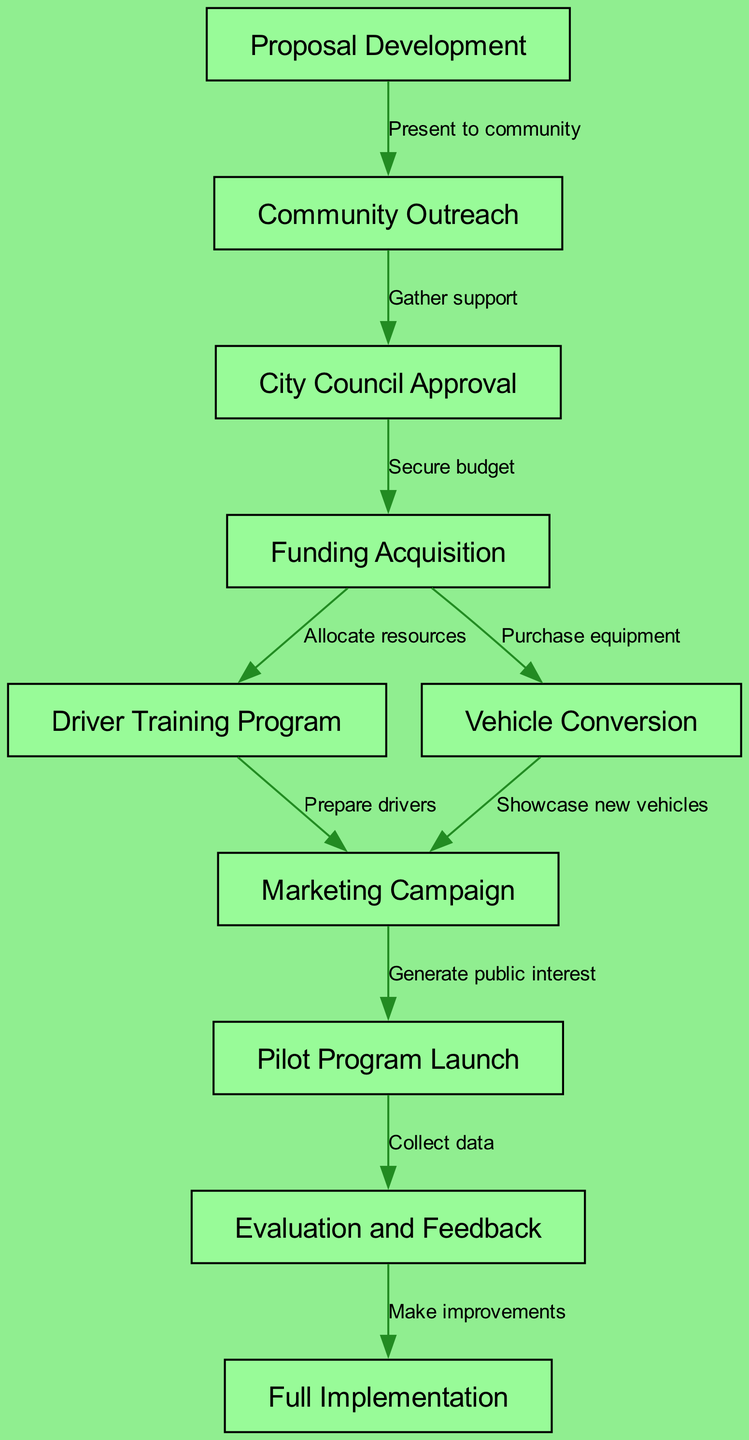What is the first step in the Green Taxi Initiative rollout plan? The first step is "Proposal Development," as indicated at the start of the diagram.
Answer: Proposal Development How many total nodes are present in the diagram? By counting the individual nodes listed in the diagram, there are a total of 10 nodes.
Answer: 10 What follows "Community Outreach" in the process? The next step after "Community Outreach" is "City Council Approval," which is shown as a direct link in the diagram.
Answer: City Council Approval Which nodes contribute to "Marketing Campaign"? "Driver Training Program" and "Vehicle Conversion" both lead to "Marketing Campaign," showing they contribute content to the campaign.
Answer: Driver Training Program, Vehicle Conversion What is the relationship between "Pilot Program Launch" and "Evaluation and Feedback"? "Pilot Program Launch" leads directly to "Evaluation and Feedback," implying that feedback is collected after the pilot's implementation.
Answer: Collect data What outcomes are expected after "Evaluation and Feedback"? The outcome expected after this step is "Full Implementation," as the diagram indicates improvements will be made based on evaluation results before this step.
Answer: Full Implementation How many edges are there in the diagram? By counting all the directed connections (arrows) between the nodes in the diagram, there are 9 edges.
Answer: 9 What is the purpose of "Funding Acquisition"? "Funding Acquisition" serves to secure the budget, as indicated by the arrow pointing to it from "City Council Approval."
Answer: Secure budget What do the arrows represent in the Green Taxi Initiative diagram? The arrows between nodes represent the progression from one step to the next, indicating the flow of actions in the initiative.
Answer: Progression from one step to the next 